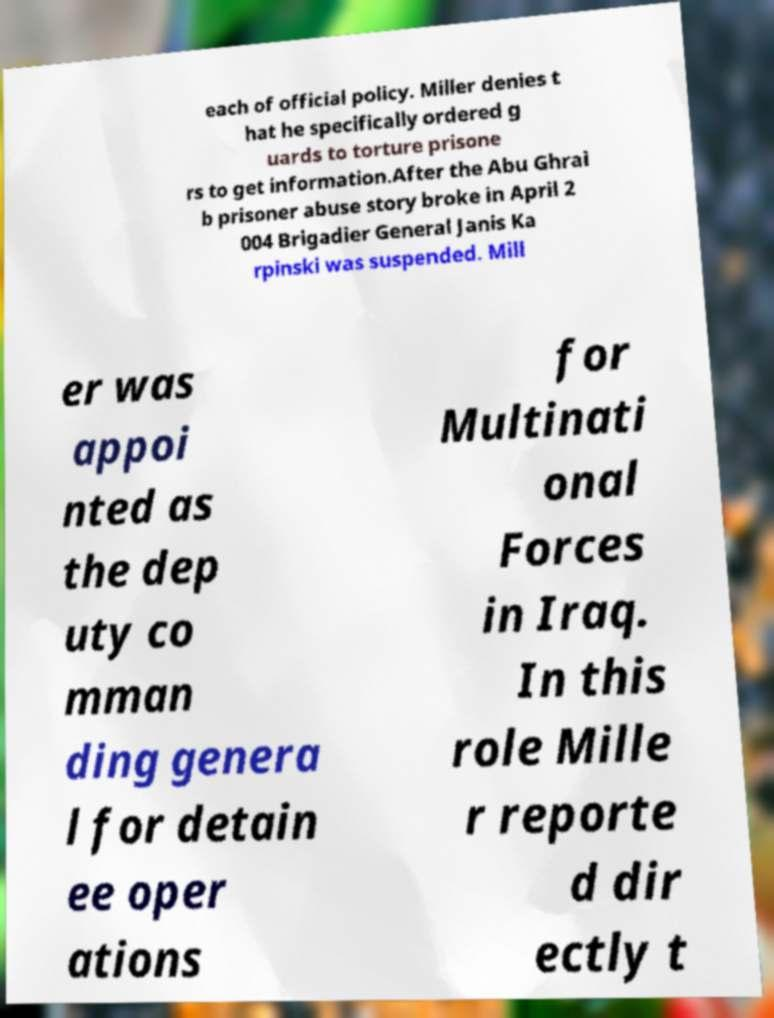Can you read and provide the text displayed in the image?This photo seems to have some interesting text. Can you extract and type it out for me? each of official policy. Miller denies t hat he specifically ordered g uards to torture prisone rs to get information.After the Abu Ghrai b prisoner abuse story broke in April 2 004 Brigadier General Janis Ka rpinski was suspended. Mill er was appoi nted as the dep uty co mman ding genera l for detain ee oper ations for Multinati onal Forces in Iraq. In this role Mille r reporte d dir ectly t 